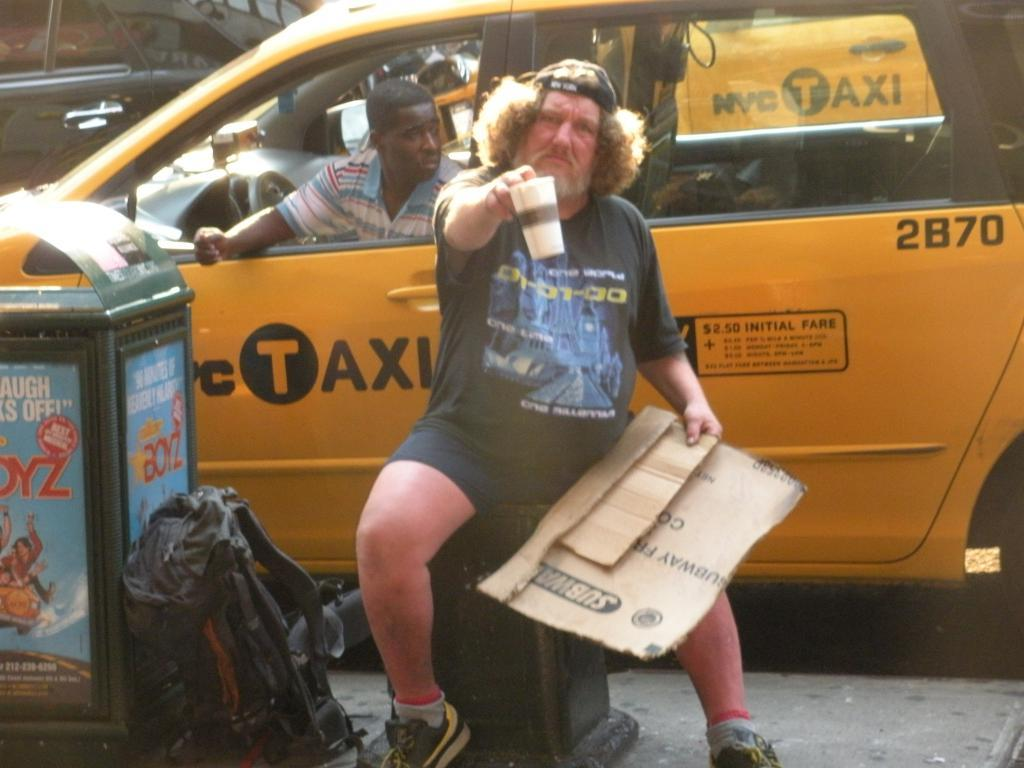Who is present in the image? There is a man in the image. What is the man doing in the image? The man is sitting in a car. What is the man holding in the image? The man is holding a cup. What objects can be seen on the floor of the car? There is a bag and a bin on the floor of the car. What type of rhythm can be heard coming from the man's cup in the image? There is no indication in the image that the man's cup is producing any rhythm or sound. 